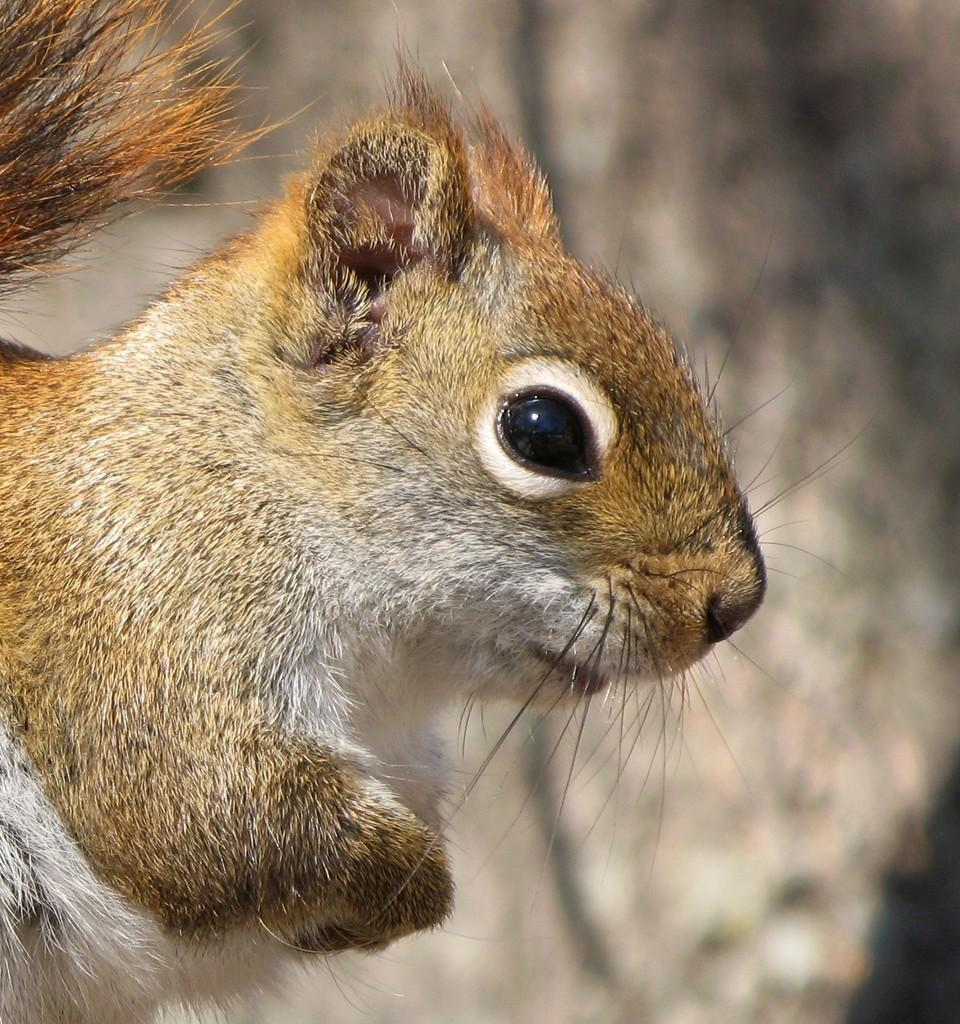What animal is in the foreground of the image? There is a squirrel in the foreground of the image. What type of ornament is hanging from the squirrel's tail in the image? There is no ornament hanging from the squirrel's tail in the image, as the fact provided does not mention any additional objects or decorations. 